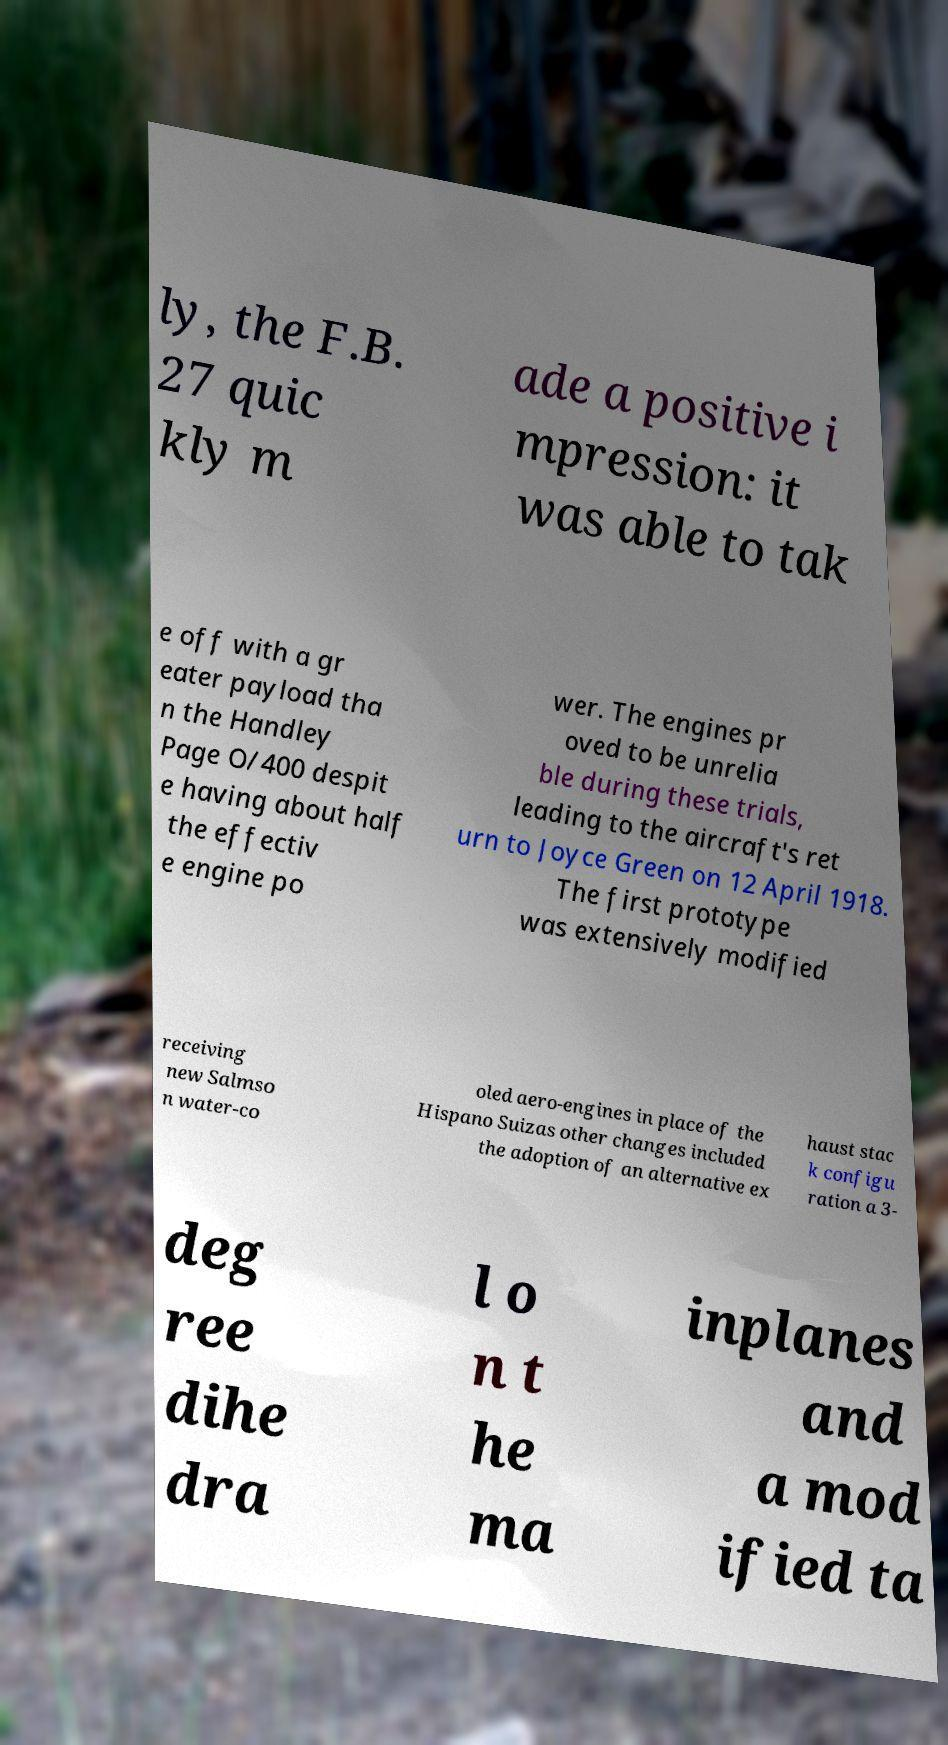I need the written content from this picture converted into text. Can you do that? ly, the F.B. 27 quic kly m ade a positive i mpression: it was able to tak e off with a gr eater payload tha n the Handley Page O/400 despit e having about half the effectiv e engine po wer. The engines pr oved to be unrelia ble during these trials, leading to the aircraft's ret urn to Joyce Green on 12 April 1918. The first prototype was extensively modified receiving new Salmso n water-co oled aero-engines in place of the Hispano Suizas other changes included the adoption of an alternative ex haust stac k configu ration a 3- deg ree dihe dra l o n t he ma inplanes and a mod ified ta 